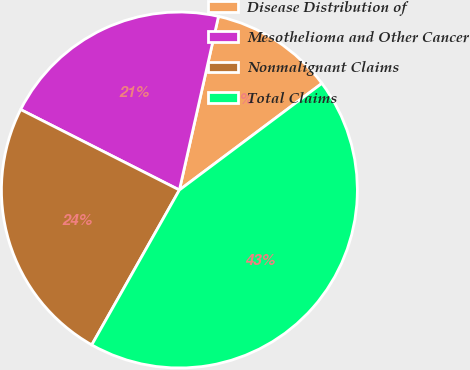Convert chart to OTSL. <chart><loc_0><loc_0><loc_500><loc_500><pie_chart><fcel>Disease Distribution of<fcel>Mesothelioma and Other Cancer<fcel>Nonmalignant Claims<fcel>Total Claims<nl><fcel>11.25%<fcel>21.06%<fcel>24.27%<fcel>43.42%<nl></chart> 